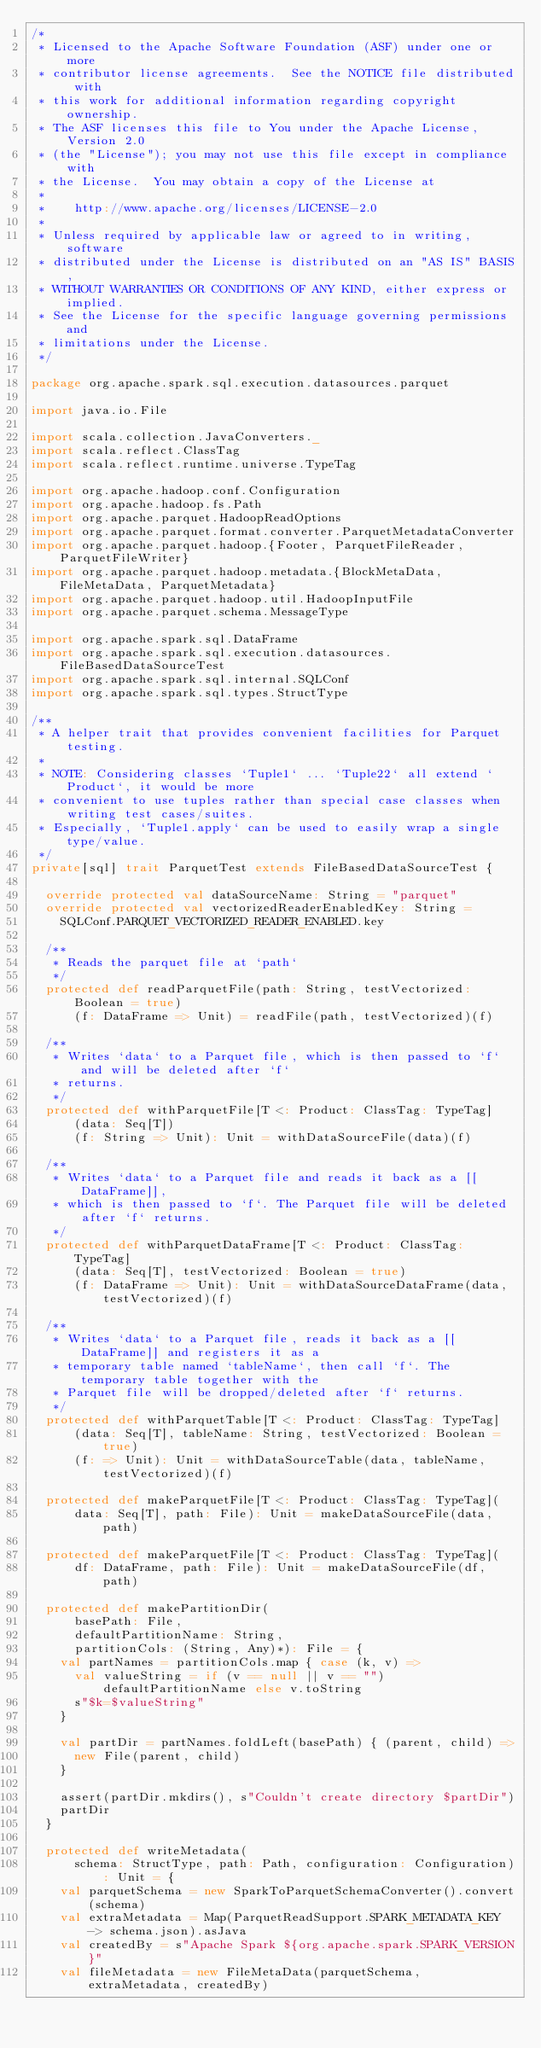Convert code to text. <code><loc_0><loc_0><loc_500><loc_500><_Scala_>/*
 * Licensed to the Apache Software Foundation (ASF) under one or more
 * contributor license agreements.  See the NOTICE file distributed with
 * this work for additional information regarding copyright ownership.
 * The ASF licenses this file to You under the Apache License, Version 2.0
 * (the "License"); you may not use this file except in compliance with
 * the License.  You may obtain a copy of the License at
 *
 *    http://www.apache.org/licenses/LICENSE-2.0
 *
 * Unless required by applicable law or agreed to in writing, software
 * distributed under the License is distributed on an "AS IS" BASIS,
 * WITHOUT WARRANTIES OR CONDITIONS OF ANY KIND, either express or implied.
 * See the License for the specific language governing permissions and
 * limitations under the License.
 */

package org.apache.spark.sql.execution.datasources.parquet

import java.io.File

import scala.collection.JavaConverters._
import scala.reflect.ClassTag
import scala.reflect.runtime.universe.TypeTag

import org.apache.hadoop.conf.Configuration
import org.apache.hadoop.fs.Path
import org.apache.parquet.HadoopReadOptions
import org.apache.parquet.format.converter.ParquetMetadataConverter
import org.apache.parquet.hadoop.{Footer, ParquetFileReader, ParquetFileWriter}
import org.apache.parquet.hadoop.metadata.{BlockMetaData, FileMetaData, ParquetMetadata}
import org.apache.parquet.hadoop.util.HadoopInputFile
import org.apache.parquet.schema.MessageType

import org.apache.spark.sql.DataFrame
import org.apache.spark.sql.execution.datasources.FileBasedDataSourceTest
import org.apache.spark.sql.internal.SQLConf
import org.apache.spark.sql.types.StructType

/**
 * A helper trait that provides convenient facilities for Parquet testing.
 *
 * NOTE: Considering classes `Tuple1` ... `Tuple22` all extend `Product`, it would be more
 * convenient to use tuples rather than special case classes when writing test cases/suites.
 * Especially, `Tuple1.apply` can be used to easily wrap a single type/value.
 */
private[sql] trait ParquetTest extends FileBasedDataSourceTest {

  override protected val dataSourceName: String = "parquet"
  override protected val vectorizedReaderEnabledKey: String =
    SQLConf.PARQUET_VECTORIZED_READER_ENABLED.key

  /**
   * Reads the parquet file at `path`
   */
  protected def readParquetFile(path: String, testVectorized: Boolean = true)
      (f: DataFrame => Unit) = readFile(path, testVectorized)(f)

  /**
   * Writes `data` to a Parquet file, which is then passed to `f` and will be deleted after `f`
   * returns.
   */
  protected def withParquetFile[T <: Product: ClassTag: TypeTag]
      (data: Seq[T])
      (f: String => Unit): Unit = withDataSourceFile(data)(f)

  /**
   * Writes `data` to a Parquet file and reads it back as a [[DataFrame]],
   * which is then passed to `f`. The Parquet file will be deleted after `f` returns.
   */
  protected def withParquetDataFrame[T <: Product: ClassTag: TypeTag]
      (data: Seq[T], testVectorized: Boolean = true)
      (f: DataFrame => Unit): Unit = withDataSourceDataFrame(data, testVectorized)(f)

  /**
   * Writes `data` to a Parquet file, reads it back as a [[DataFrame]] and registers it as a
   * temporary table named `tableName`, then call `f`. The temporary table together with the
   * Parquet file will be dropped/deleted after `f` returns.
   */
  protected def withParquetTable[T <: Product: ClassTag: TypeTag]
      (data: Seq[T], tableName: String, testVectorized: Boolean = true)
      (f: => Unit): Unit = withDataSourceTable(data, tableName, testVectorized)(f)

  protected def makeParquetFile[T <: Product: ClassTag: TypeTag](
      data: Seq[T], path: File): Unit = makeDataSourceFile(data, path)

  protected def makeParquetFile[T <: Product: ClassTag: TypeTag](
      df: DataFrame, path: File): Unit = makeDataSourceFile(df, path)

  protected def makePartitionDir(
      basePath: File,
      defaultPartitionName: String,
      partitionCols: (String, Any)*): File = {
    val partNames = partitionCols.map { case (k, v) =>
      val valueString = if (v == null || v == "") defaultPartitionName else v.toString
      s"$k=$valueString"
    }

    val partDir = partNames.foldLeft(basePath) { (parent, child) =>
      new File(parent, child)
    }

    assert(partDir.mkdirs(), s"Couldn't create directory $partDir")
    partDir
  }

  protected def writeMetadata(
      schema: StructType, path: Path, configuration: Configuration): Unit = {
    val parquetSchema = new SparkToParquetSchemaConverter().convert(schema)
    val extraMetadata = Map(ParquetReadSupport.SPARK_METADATA_KEY -> schema.json).asJava
    val createdBy = s"Apache Spark ${org.apache.spark.SPARK_VERSION}"
    val fileMetadata = new FileMetaData(parquetSchema, extraMetadata, createdBy)</code> 